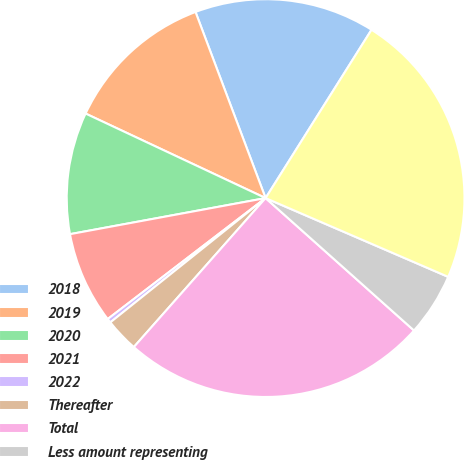Convert chart to OTSL. <chart><loc_0><loc_0><loc_500><loc_500><pie_chart><fcel>2018<fcel>2019<fcel>2020<fcel>2021<fcel>2022<fcel>Thereafter<fcel>Total<fcel>Less amount representing<fcel>Capital lease obligations<nl><fcel>14.67%<fcel>12.28%<fcel>9.89%<fcel>7.5%<fcel>0.34%<fcel>2.73%<fcel>24.93%<fcel>5.11%<fcel>22.54%<nl></chart> 